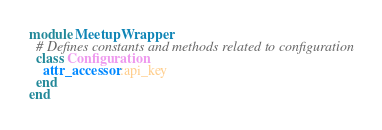Convert code to text. <code><loc_0><loc_0><loc_500><loc_500><_Ruby_>module MeetupWrapper
  # Defines constants and methods related to configuration
  class Configuration
    attr_accessor :api_key
  end
end
</code> 